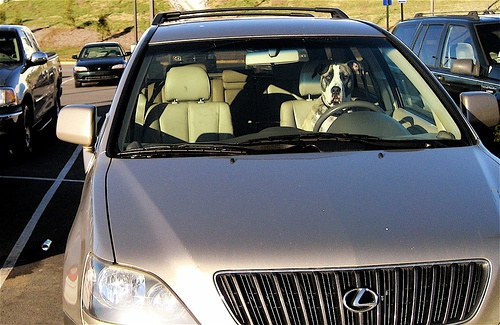Describe the objects in this image and their specific colors. I can see car in white, black, gray, and darkgray tones, truck in white, black, gray, and blue tones, truck in white, black, gray, ivory, and tan tones, dog in white, black, gray, khaki, and lightyellow tones, and car in white, black, gray, navy, and darkblue tones in this image. 